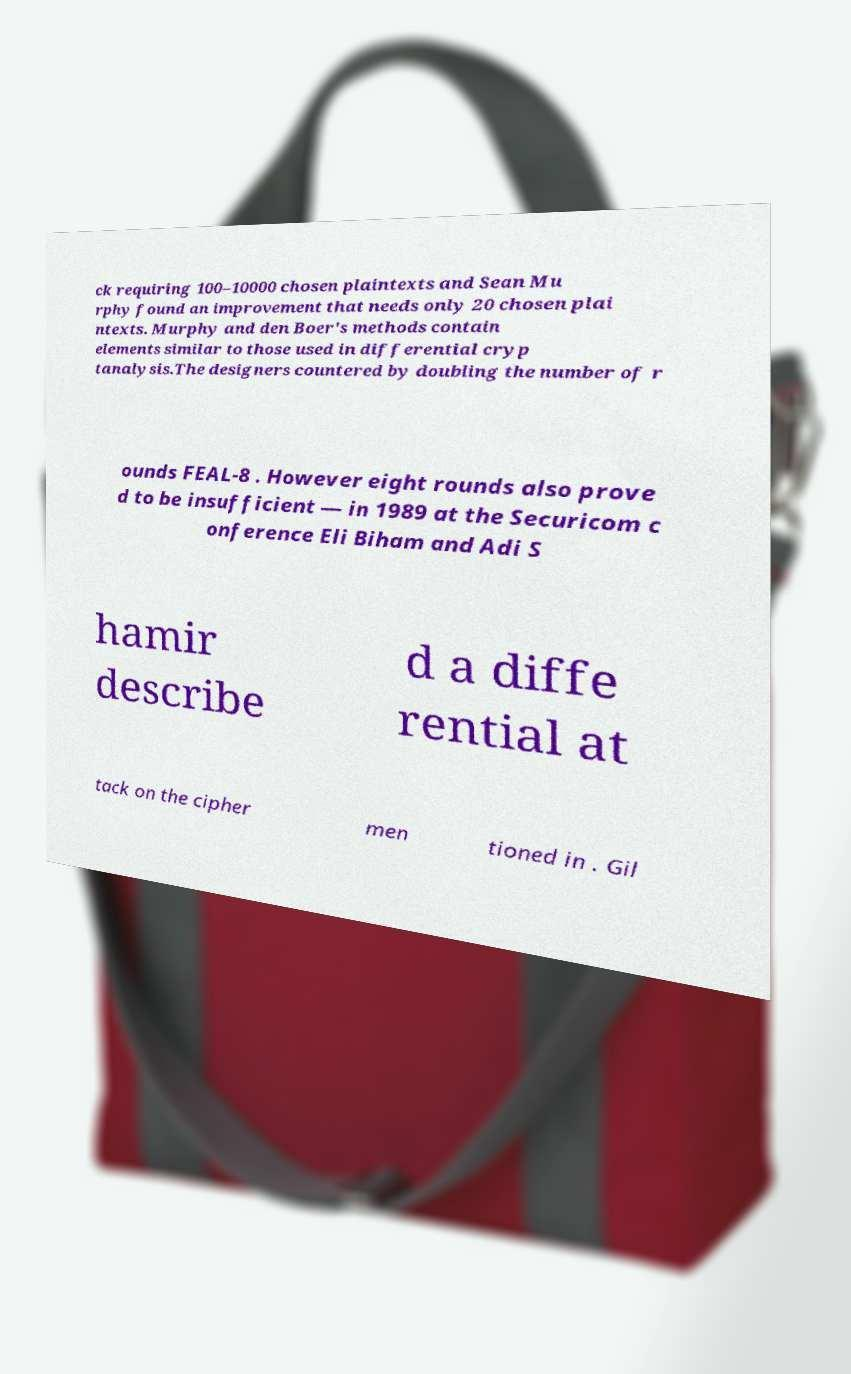Can you read and provide the text displayed in the image?This photo seems to have some interesting text. Can you extract and type it out for me? ck requiring 100–10000 chosen plaintexts and Sean Mu rphy found an improvement that needs only 20 chosen plai ntexts. Murphy and den Boer's methods contain elements similar to those used in differential cryp tanalysis.The designers countered by doubling the number of r ounds FEAL-8 . However eight rounds also prove d to be insufficient — in 1989 at the Securicom c onference Eli Biham and Adi S hamir describe d a diffe rential at tack on the cipher men tioned in . Gil 